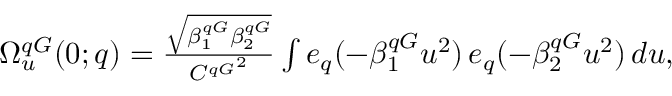<formula> <loc_0><loc_0><loc_500><loc_500>\begin{array} { r } { \Omega _ { u } ^ { q G } ( 0 ; q ) = \frac { \sqrt { \beta _ { 1 } ^ { q G } \beta _ { 2 } ^ { q G } } } { { C ^ { q G } } ^ { 2 } } \int e _ { q } ( - \beta _ { 1 } ^ { q G } u ^ { 2 } ) \, e _ { q } ( - \beta _ { 2 } ^ { q G } u ^ { 2 } ) \, d u , } \end{array}</formula> 